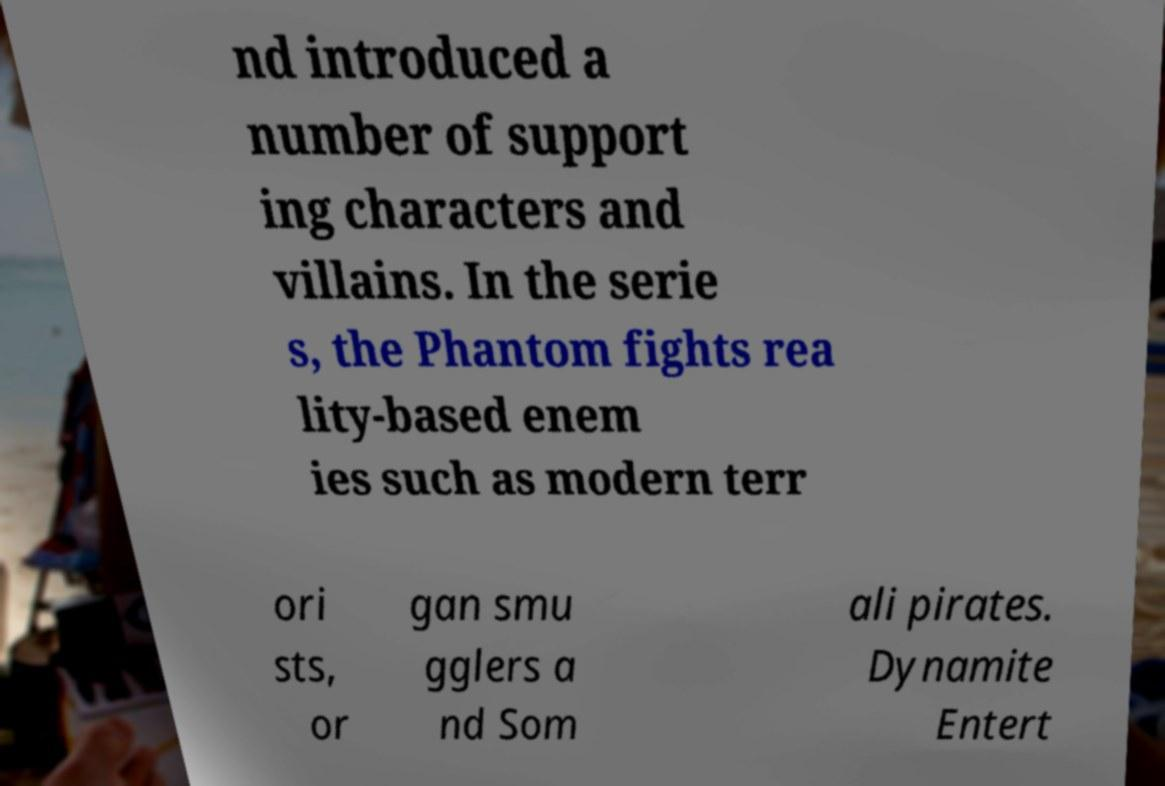Please read and relay the text visible in this image. What does it say? nd introduced a number of support ing characters and villains. In the serie s, the Phantom fights rea lity-based enem ies such as modern terr ori sts, or gan smu gglers a nd Som ali pirates. Dynamite Entert 